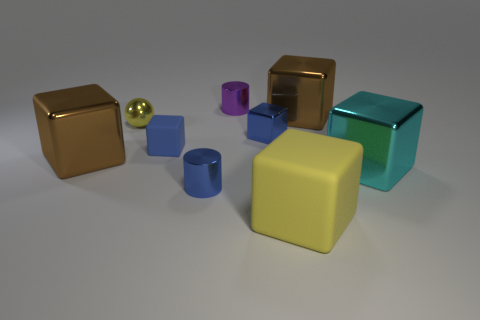Subtract all big yellow cubes. How many cubes are left? 5 Subtract all yellow cylinders. How many brown cubes are left? 2 Subtract all yellow cubes. How many cubes are left? 5 Subtract all spheres. How many objects are left? 8 Add 3 small shiny things. How many small shiny things exist? 7 Subtract 1 yellow balls. How many objects are left? 8 Subtract all red cylinders. Subtract all blue balls. How many cylinders are left? 2 Subtract all big gray metal things. Subtract all big brown blocks. How many objects are left? 7 Add 4 tiny blue shiny objects. How many tiny blue shiny objects are left? 6 